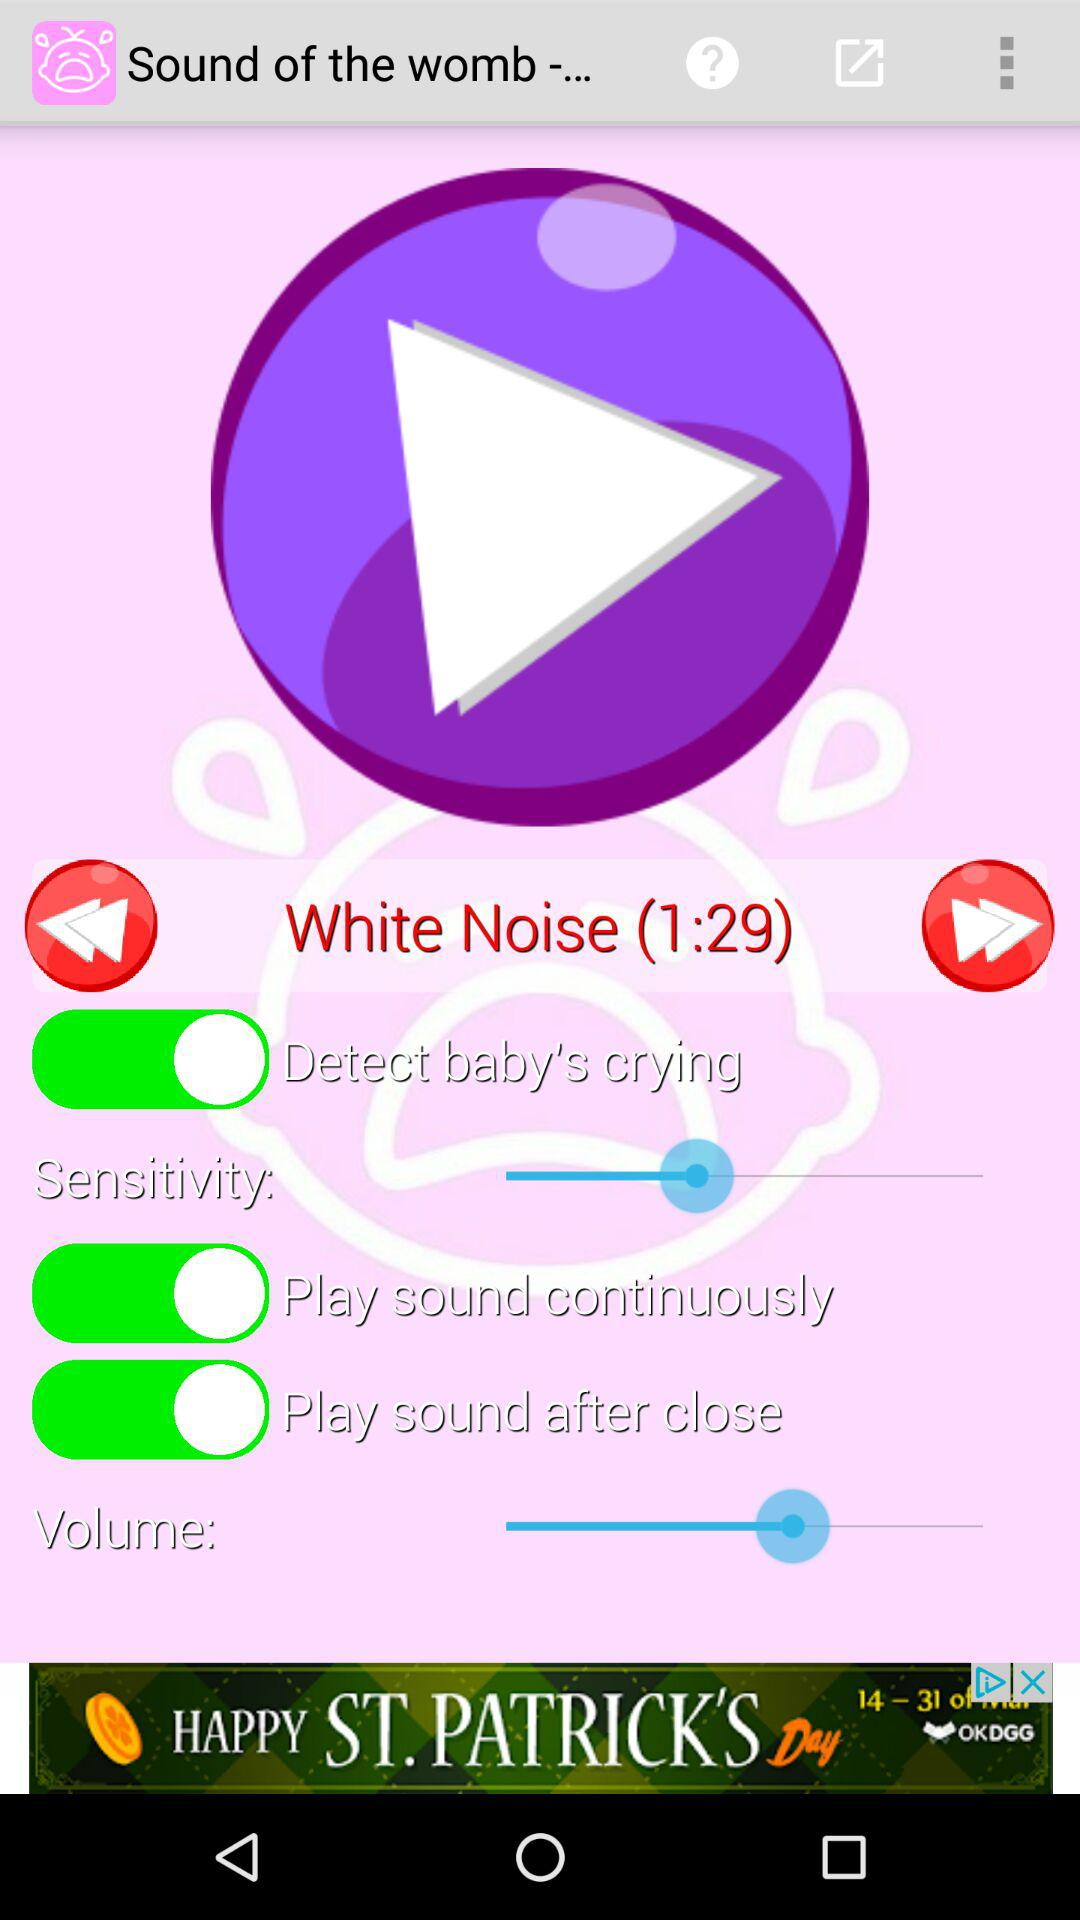What is the current status of the "Play sound after close"? The current status of the "Play sound after close" is "on". 